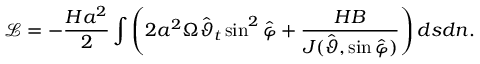<formula> <loc_0><loc_0><loc_500><loc_500>\mathcal { L } = - \frac { H a ^ { 2 } } { 2 } \int \left ( 2 a ^ { 2 } \Omega \hat { \vartheta } _ { t } \sin ^ { 2 } \hat { \varphi } + \frac { H B } { J ( \hat { \vartheta } , \sin \hat { \varphi } ) } \right ) d s d n .</formula> 